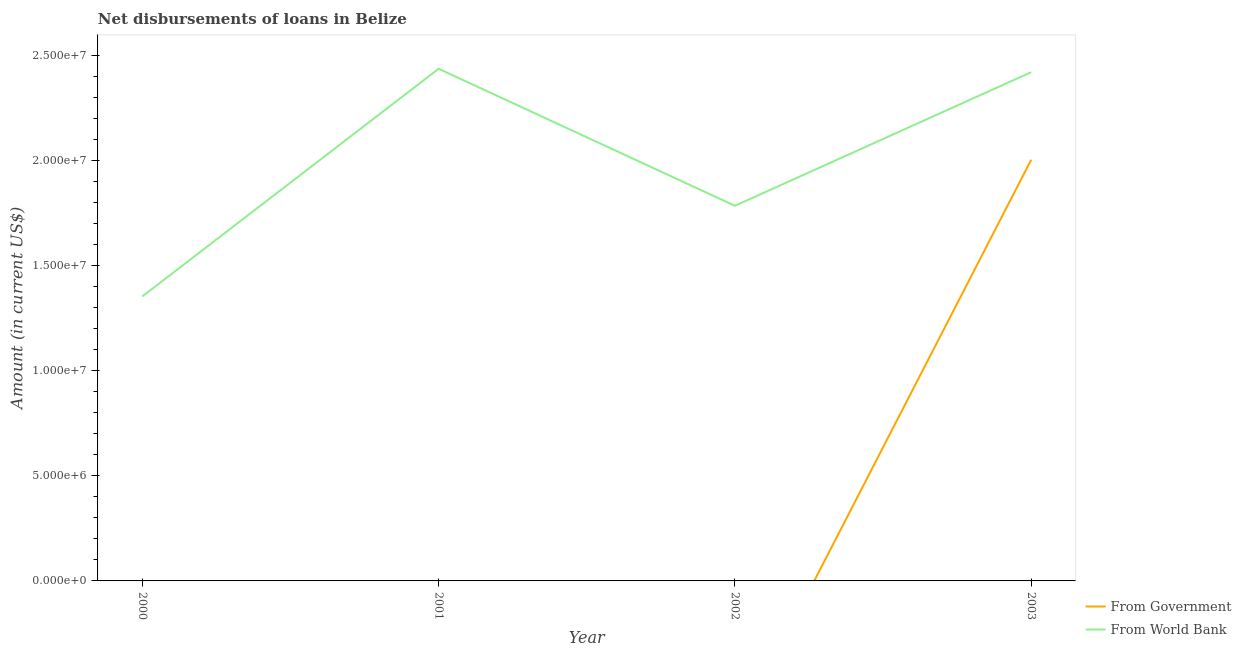How many different coloured lines are there?
Provide a succinct answer. 2. Does the line corresponding to net disbursements of loan from world bank intersect with the line corresponding to net disbursements of loan from government?
Provide a succinct answer. No. What is the net disbursements of loan from world bank in 2002?
Offer a very short reply. 1.78e+07. Across all years, what is the maximum net disbursements of loan from government?
Provide a succinct answer. 2.00e+07. Across all years, what is the minimum net disbursements of loan from world bank?
Your answer should be compact. 1.35e+07. In which year was the net disbursements of loan from government maximum?
Ensure brevity in your answer.  2003. What is the total net disbursements of loan from government in the graph?
Make the answer very short. 2.00e+07. What is the difference between the net disbursements of loan from world bank in 2000 and that in 2001?
Your answer should be compact. -1.08e+07. What is the difference between the net disbursements of loan from world bank in 2003 and the net disbursements of loan from government in 2002?
Your answer should be very brief. 2.42e+07. What is the average net disbursements of loan from world bank per year?
Provide a succinct answer. 2.00e+07. In the year 2003, what is the difference between the net disbursements of loan from government and net disbursements of loan from world bank?
Ensure brevity in your answer.  -4.16e+06. In how many years, is the net disbursements of loan from government greater than 8000000 US$?
Provide a succinct answer. 1. What is the ratio of the net disbursements of loan from world bank in 2000 to that in 2002?
Ensure brevity in your answer.  0.76. What is the difference between the highest and the second highest net disbursements of loan from world bank?
Offer a terse response. 1.61e+05. What is the difference between the highest and the lowest net disbursements of loan from government?
Offer a very short reply. 2.00e+07. Is the net disbursements of loan from government strictly greater than the net disbursements of loan from world bank over the years?
Keep it short and to the point. No. Does the graph contain grids?
Your answer should be very brief. No. Where does the legend appear in the graph?
Provide a succinct answer. Bottom right. How many legend labels are there?
Keep it short and to the point. 2. How are the legend labels stacked?
Your answer should be compact. Vertical. What is the title of the graph?
Offer a terse response. Net disbursements of loans in Belize. What is the Amount (in current US$) of From World Bank in 2000?
Make the answer very short. 1.35e+07. What is the Amount (in current US$) of From World Bank in 2001?
Your answer should be compact. 2.44e+07. What is the Amount (in current US$) in From World Bank in 2002?
Make the answer very short. 1.78e+07. What is the Amount (in current US$) of From Government in 2003?
Your response must be concise. 2.00e+07. What is the Amount (in current US$) of From World Bank in 2003?
Offer a very short reply. 2.42e+07. Across all years, what is the maximum Amount (in current US$) in From Government?
Offer a very short reply. 2.00e+07. Across all years, what is the maximum Amount (in current US$) of From World Bank?
Give a very brief answer. 2.44e+07. Across all years, what is the minimum Amount (in current US$) in From World Bank?
Make the answer very short. 1.35e+07. What is the total Amount (in current US$) in From Government in the graph?
Keep it short and to the point. 2.00e+07. What is the total Amount (in current US$) in From World Bank in the graph?
Give a very brief answer. 7.99e+07. What is the difference between the Amount (in current US$) in From World Bank in 2000 and that in 2001?
Give a very brief answer. -1.08e+07. What is the difference between the Amount (in current US$) of From World Bank in 2000 and that in 2002?
Give a very brief answer. -4.31e+06. What is the difference between the Amount (in current US$) of From World Bank in 2000 and that in 2003?
Make the answer very short. -1.07e+07. What is the difference between the Amount (in current US$) in From World Bank in 2001 and that in 2002?
Keep it short and to the point. 6.52e+06. What is the difference between the Amount (in current US$) in From World Bank in 2001 and that in 2003?
Offer a terse response. 1.61e+05. What is the difference between the Amount (in current US$) of From World Bank in 2002 and that in 2003?
Offer a terse response. -6.36e+06. What is the average Amount (in current US$) of From Government per year?
Your answer should be very brief. 5.01e+06. What is the average Amount (in current US$) of From World Bank per year?
Your answer should be very brief. 2.00e+07. In the year 2003, what is the difference between the Amount (in current US$) of From Government and Amount (in current US$) of From World Bank?
Your response must be concise. -4.16e+06. What is the ratio of the Amount (in current US$) of From World Bank in 2000 to that in 2001?
Offer a terse response. 0.56. What is the ratio of the Amount (in current US$) of From World Bank in 2000 to that in 2002?
Your response must be concise. 0.76. What is the ratio of the Amount (in current US$) of From World Bank in 2000 to that in 2003?
Your answer should be very brief. 0.56. What is the ratio of the Amount (in current US$) of From World Bank in 2001 to that in 2002?
Provide a succinct answer. 1.37. What is the ratio of the Amount (in current US$) in From World Bank in 2002 to that in 2003?
Provide a short and direct response. 0.74. What is the difference between the highest and the second highest Amount (in current US$) of From World Bank?
Ensure brevity in your answer.  1.61e+05. What is the difference between the highest and the lowest Amount (in current US$) in From Government?
Make the answer very short. 2.00e+07. What is the difference between the highest and the lowest Amount (in current US$) in From World Bank?
Keep it short and to the point. 1.08e+07. 